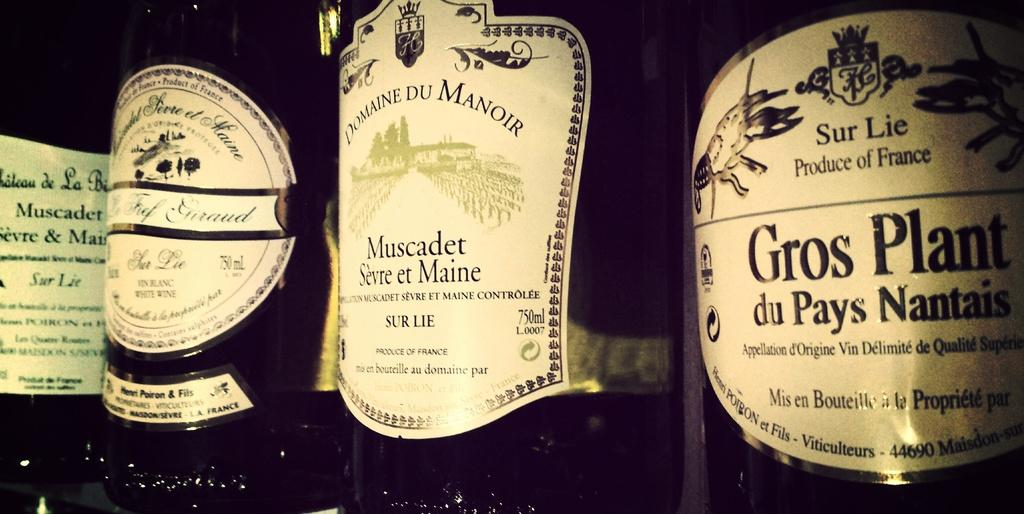<image>
Render a clear and concise summary of the photo. A bottle of Domaine Du Manoir wine that was made in France. 